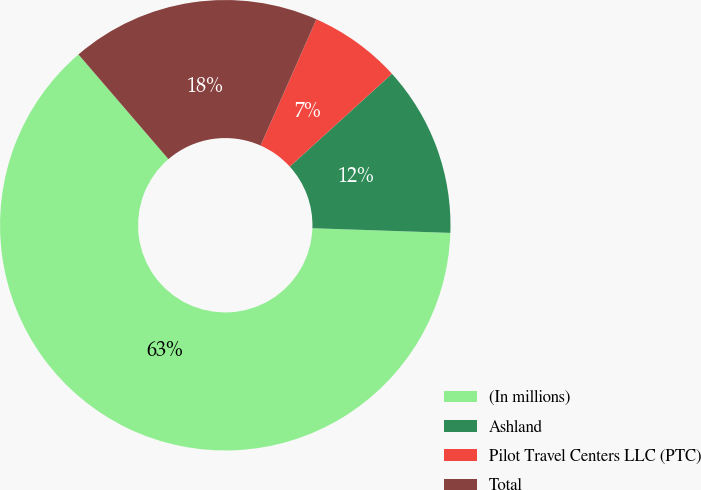Convert chart. <chart><loc_0><loc_0><loc_500><loc_500><pie_chart><fcel>(In millions)<fcel>Ashland<fcel>Pilot Travel Centers LLC (PTC)<fcel>Total<nl><fcel>63.16%<fcel>12.28%<fcel>6.63%<fcel>17.93%<nl></chart> 